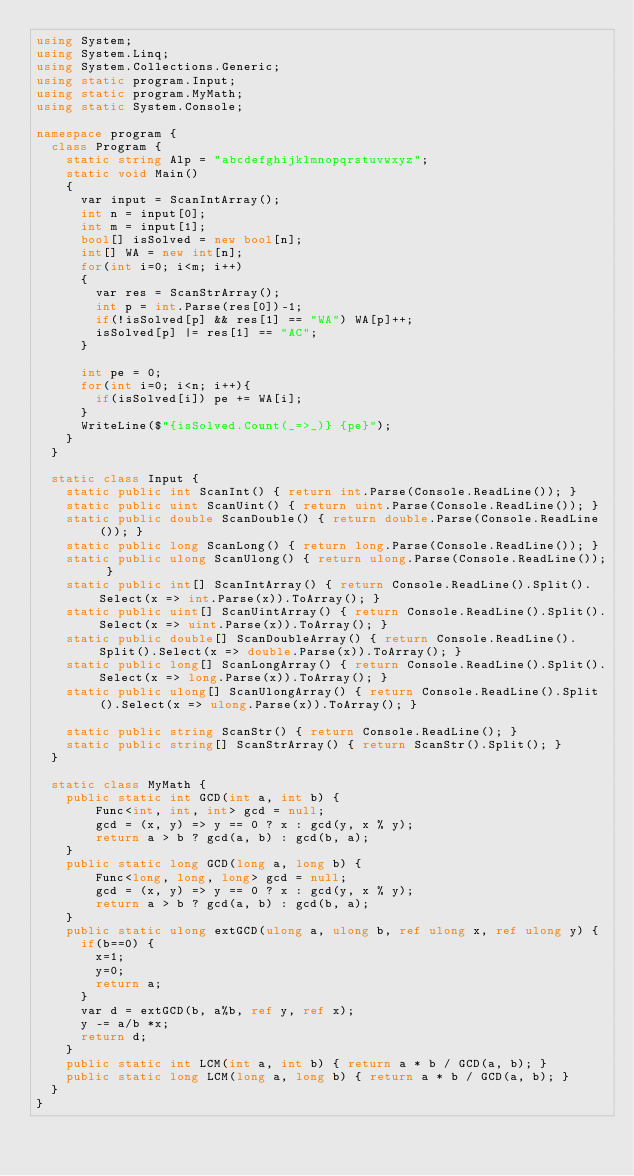<code> <loc_0><loc_0><loc_500><loc_500><_C#_>using System;
using System.Linq;
using System.Collections.Generic;
using static program.Input;
using static program.MyMath;
using static System.Console;

namespace program {
  class Program {
    static string Alp = "abcdefghijklmnopqrstuvwxyz";
    static void Main()
    {
      var input = ScanIntArray();
      int n = input[0];
      int m = input[1];
      bool[] isSolved = new bool[n];
      int[] WA = new int[n];
      for(int i=0; i<m; i++)
      {
        var res = ScanStrArray();
        int p = int.Parse(res[0])-1;
        if(!isSolved[p] && res[1] == "WA") WA[p]++;
        isSolved[p] |= res[1] == "AC";
      }
      
      int pe = 0;
      for(int i=0; i<n; i++){
        if(isSolved[i]) pe += WA[i];
      }
      WriteLine($"{isSolved.Count(_=>_)} {pe}");
    }
  }
  
  static class Input {
    static public int ScanInt() { return int.Parse(Console.ReadLine()); }
    static public uint ScanUint() { return uint.Parse(Console.ReadLine()); }
    static public double ScanDouble() { return double.Parse(Console.ReadLine()); }
    static public long ScanLong() { return long.Parse(Console.ReadLine()); }
    static public ulong ScanUlong() { return ulong.Parse(Console.ReadLine()); }
    static public int[] ScanIntArray() { return Console.ReadLine().Split().Select(x => int.Parse(x)).ToArray(); }
    static public uint[] ScanUintArray() { return Console.ReadLine().Split().Select(x => uint.Parse(x)).ToArray(); }
    static public double[] ScanDoubleArray() { return Console.ReadLine().Split().Select(x => double.Parse(x)).ToArray(); }
    static public long[] ScanLongArray() { return Console.ReadLine().Split().Select(x => long.Parse(x)).ToArray(); }
    static public ulong[] ScanUlongArray() { return Console.ReadLine().Split().Select(x => ulong.Parse(x)).ToArray(); }

    static public string ScanStr() { return Console.ReadLine(); }
    static public string[] ScanStrArray() { return ScanStr().Split(); }
  }
  
  static class MyMath {
    public static int GCD(int a, int b) {
        Func<int, int, int> gcd = null;
        gcd = (x, y) => y == 0 ? x : gcd(y, x % y);
        return a > b ? gcd(a, b) : gcd(b, a);
    }
    public static long GCD(long a, long b) {
        Func<long, long, long> gcd = null;
        gcd = (x, y) => y == 0 ? x : gcd(y, x % y);
        return a > b ? gcd(a, b) : gcd(b, a);
    }
    public static ulong extGCD(ulong a, ulong b, ref ulong x, ref ulong y) {
      if(b==0) {
        x=1; 
        y=0;
        return a;
      }
      var d = extGCD(b, a%b, ref y, ref x);
      y -= a/b *x;
      return d;
    }
    public static int LCM(int a, int b) { return a * b / GCD(a, b); }
    public static long LCM(long a, long b) { return a * b / GCD(a, b); }
  }
}
</code> 